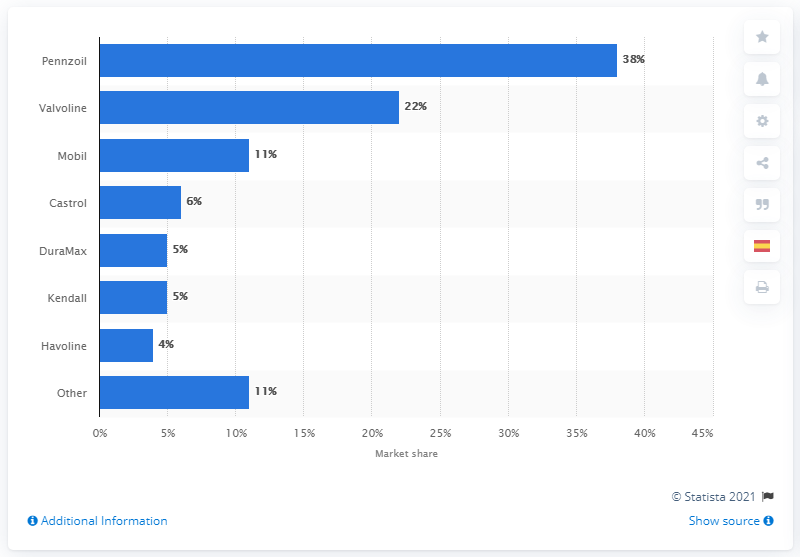Highlight a few significant elements in this photo. In 2018, Pennzoil held a market share of 38% in the synthetic motor oil segment for fast lubes. In 2018, Pennzoil was the company that held the largest share of synthetic motor oils sold in fast lubes in the United States. 